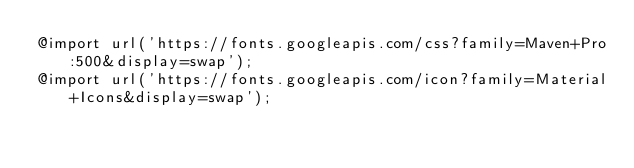Convert code to text. <code><loc_0><loc_0><loc_500><loc_500><_CSS_>@import url('https://fonts.googleapis.com/css?family=Maven+Pro:500&display=swap');
@import url('https://fonts.googleapis.com/icon?family=Material+Icons&display=swap');</code> 